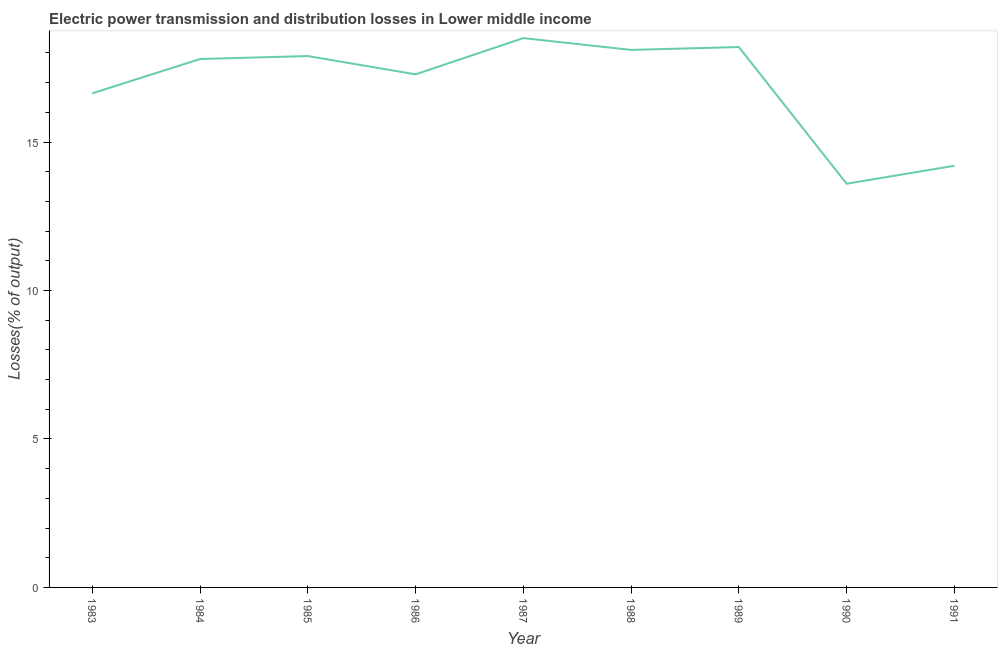What is the electric power transmission and distribution losses in 1983?
Provide a succinct answer. 16.64. Across all years, what is the maximum electric power transmission and distribution losses?
Provide a succinct answer. 18.5. Across all years, what is the minimum electric power transmission and distribution losses?
Keep it short and to the point. 13.6. What is the sum of the electric power transmission and distribution losses?
Provide a short and direct response. 152.21. What is the difference between the electric power transmission and distribution losses in 1983 and 1986?
Offer a very short reply. -0.64. What is the average electric power transmission and distribution losses per year?
Your response must be concise. 16.91. What is the median electric power transmission and distribution losses?
Keep it short and to the point. 17.79. In how many years, is the electric power transmission and distribution losses greater than 12 %?
Your answer should be very brief. 9. What is the ratio of the electric power transmission and distribution losses in 1985 to that in 1990?
Provide a succinct answer. 1.32. What is the difference between the highest and the second highest electric power transmission and distribution losses?
Your response must be concise. 0.3. Is the sum of the electric power transmission and distribution losses in 1985 and 1987 greater than the maximum electric power transmission and distribution losses across all years?
Ensure brevity in your answer.  Yes. What is the difference between the highest and the lowest electric power transmission and distribution losses?
Ensure brevity in your answer.  4.9. In how many years, is the electric power transmission and distribution losses greater than the average electric power transmission and distribution losses taken over all years?
Give a very brief answer. 6. Does the electric power transmission and distribution losses monotonically increase over the years?
Your answer should be compact. No. Are the values on the major ticks of Y-axis written in scientific E-notation?
Ensure brevity in your answer.  No. Does the graph contain any zero values?
Make the answer very short. No. What is the title of the graph?
Give a very brief answer. Electric power transmission and distribution losses in Lower middle income. What is the label or title of the X-axis?
Give a very brief answer. Year. What is the label or title of the Y-axis?
Give a very brief answer. Losses(% of output). What is the Losses(% of output) of 1983?
Your answer should be very brief. 16.64. What is the Losses(% of output) in 1984?
Provide a succinct answer. 17.79. What is the Losses(% of output) in 1985?
Give a very brief answer. 17.9. What is the Losses(% of output) in 1986?
Your answer should be compact. 17.28. What is the Losses(% of output) in 1987?
Your answer should be compact. 18.5. What is the Losses(% of output) of 1988?
Provide a succinct answer. 18.1. What is the Losses(% of output) in 1989?
Your answer should be very brief. 18.2. What is the Losses(% of output) of 1990?
Provide a succinct answer. 13.6. What is the Losses(% of output) in 1991?
Offer a terse response. 14.2. What is the difference between the Losses(% of output) in 1983 and 1984?
Ensure brevity in your answer.  -1.16. What is the difference between the Losses(% of output) in 1983 and 1985?
Your response must be concise. -1.26. What is the difference between the Losses(% of output) in 1983 and 1986?
Ensure brevity in your answer.  -0.64. What is the difference between the Losses(% of output) in 1983 and 1987?
Provide a short and direct response. -1.86. What is the difference between the Losses(% of output) in 1983 and 1988?
Your response must be concise. -1.46. What is the difference between the Losses(% of output) in 1983 and 1989?
Keep it short and to the point. -1.56. What is the difference between the Losses(% of output) in 1983 and 1990?
Keep it short and to the point. 3.04. What is the difference between the Losses(% of output) in 1983 and 1991?
Your response must be concise. 2.44. What is the difference between the Losses(% of output) in 1984 and 1985?
Your response must be concise. -0.1. What is the difference between the Losses(% of output) in 1984 and 1986?
Provide a succinct answer. 0.52. What is the difference between the Losses(% of output) in 1984 and 1987?
Your answer should be compact. -0.7. What is the difference between the Losses(% of output) in 1984 and 1988?
Provide a short and direct response. -0.31. What is the difference between the Losses(% of output) in 1984 and 1989?
Ensure brevity in your answer.  -0.4. What is the difference between the Losses(% of output) in 1984 and 1990?
Offer a very short reply. 4.2. What is the difference between the Losses(% of output) in 1984 and 1991?
Make the answer very short. 3.59. What is the difference between the Losses(% of output) in 1985 and 1986?
Provide a succinct answer. 0.62. What is the difference between the Losses(% of output) in 1985 and 1987?
Keep it short and to the point. -0.6. What is the difference between the Losses(% of output) in 1985 and 1988?
Offer a terse response. -0.21. What is the difference between the Losses(% of output) in 1985 and 1989?
Provide a short and direct response. -0.3. What is the difference between the Losses(% of output) in 1985 and 1990?
Provide a short and direct response. 4.3. What is the difference between the Losses(% of output) in 1985 and 1991?
Provide a succinct answer. 3.69. What is the difference between the Losses(% of output) in 1986 and 1987?
Offer a very short reply. -1.22. What is the difference between the Losses(% of output) in 1986 and 1988?
Your answer should be compact. -0.82. What is the difference between the Losses(% of output) in 1986 and 1989?
Your answer should be compact. -0.92. What is the difference between the Losses(% of output) in 1986 and 1990?
Your response must be concise. 3.68. What is the difference between the Losses(% of output) in 1986 and 1991?
Give a very brief answer. 3.08. What is the difference between the Losses(% of output) in 1987 and 1988?
Make the answer very short. 0.4. What is the difference between the Losses(% of output) in 1987 and 1989?
Your response must be concise. 0.3. What is the difference between the Losses(% of output) in 1987 and 1990?
Give a very brief answer. 4.9. What is the difference between the Losses(% of output) in 1987 and 1991?
Your answer should be very brief. 4.3. What is the difference between the Losses(% of output) in 1988 and 1989?
Provide a succinct answer. -0.1. What is the difference between the Losses(% of output) in 1988 and 1990?
Ensure brevity in your answer.  4.51. What is the difference between the Losses(% of output) in 1988 and 1991?
Provide a short and direct response. 3.9. What is the difference between the Losses(% of output) in 1989 and 1990?
Provide a short and direct response. 4.6. What is the difference between the Losses(% of output) in 1989 and 1991?
Offer a terse response. 4. What is the difference between the Losses(% of output) in 1990 and 1991?
Offer a terse response. -0.6. What is the ratio of the Losses(% of output) in 1983 to that in 1984?
Offer a terse response. 0.94. What is the ratio of the Losses(% of output) in 1983 to that in 1985?
Keep it short and to the point. 0.93. What is the ratio of the Losses(% of output) in 1983 to that in 1986?
Ensure brevity in your answer.  0.96. What is the ratio of the Losses(% of output) in 1983 to that in 1987?
Offer a terse response. 0.9. What is the ratio of the Losses(% of output) in 1983 to that in 1988?
Make the answer very short. 0.92. What is the ratio of the Losses(% of output) in 1983 to that in 1989?
Your response must be concise. 0.91. What is the ratio of the Losses(% of output) in 1983 to that in 1990?
Your response must be concise. 1.22. What is the ratio of the Losses(% of output) in 1983 to that in 1991?
Keep it short and to the point. 1.17. What is the ratio of the Losses(% of output) in 1984 to that in 1985?
Your response must be concise. 0.99. What is the ratio of the Losses(% of output) in 1984 to that in 1986?
Offer a very short reply. 1.03. What is the ratio of the Losses(% of output) in 1984 to that in 1990?
Provide a short and direct response. 1.31. What is the ratio of the Losses(% of output) in 1984 to that in 1991?
Make the answer very short. 1.25. What is the ratio of the Losses(% of output) in 1985 to that in 1986?
Provide a short and direct response. 1.04. What is the ratio of the Losses(% of output) in 1985 to that in 1990?
Give a very brief answer. 1.32. What is the ratio of the Losses(% of output) in 1985 to that in 1991?
Give a very brief answer. 1.26. What is the ratio of the Losses(% of output) in 1986 to that in 1987?
Give a very brief answer. 0.93. What is the ratio of the Losses(% of output) in 1986 to that in 1988?
Make the answer very short. 0.95. What is the ratio of the Losses(% of output) in 1986 to that in 1989?
Give a very brief answer. 0.95. What is the ratio of the Losses(% of output) in 1986 to that in 1990?
Offer a terse response. 1.27. What is the ratio of the Losses(% of output) in 1986 to that in 1991?
Your answer should be compact. 1.22. What is the ratio of the Losses(% of output) in 1987 to that in 1988?
Offer a very short reply. 1.02. What is the ratio of the Losses(% of output) in 1987 to that in 1989?
Offer a very short reply. 1.02. What is the ratio of the Losses(% of output) in 1987 to that in 1990?
Make the answer very short. 1.36. What is the ratio of the Losses(% of output) in 1987 to that in 1991?
Make the answer very short. 1.3. What is the ratio of the Losses(% of output) in 1988 to that in 1990?
Your answer should be very brief. 1.33. What is the ratio of the Losses(% of output) in 1988 to that in 1991?
Provide a succinct answer. 1.27. What is the ratio of the Losses(% of output) in 1989 to that in 1990?
Provide a short and direct response. 1.34. What is the ratio of the Losses(% of output) in 1989 to that in 1991?
Keep it short and to the point. 1.28. 